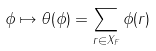Convert formula to latex. <formula><loc_0><loc_0><loc_500><loc_500>\phi \mapsto \theta ( \phi ) = \sum _ { r \in X _ { F } } \phi ( r )</formula> 